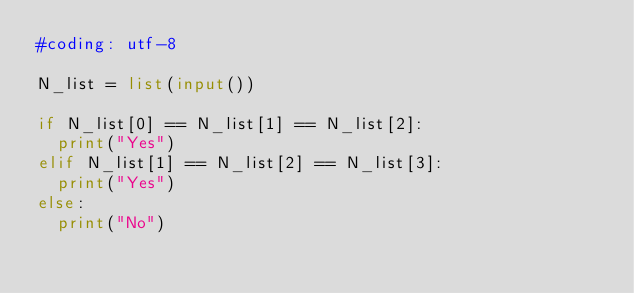Convert code to text. <code><loc_0><loc_0><loc_500><loc_500><_Python_>#coding: utf-8

N_list = list(input())

if N_list[0] == N_list[1] == N_list[2]:
	print("Yes")
elif N_list[1] == N_list[2] == N_list[3]:
	print("Yes")
else:
	print("No")</code> 